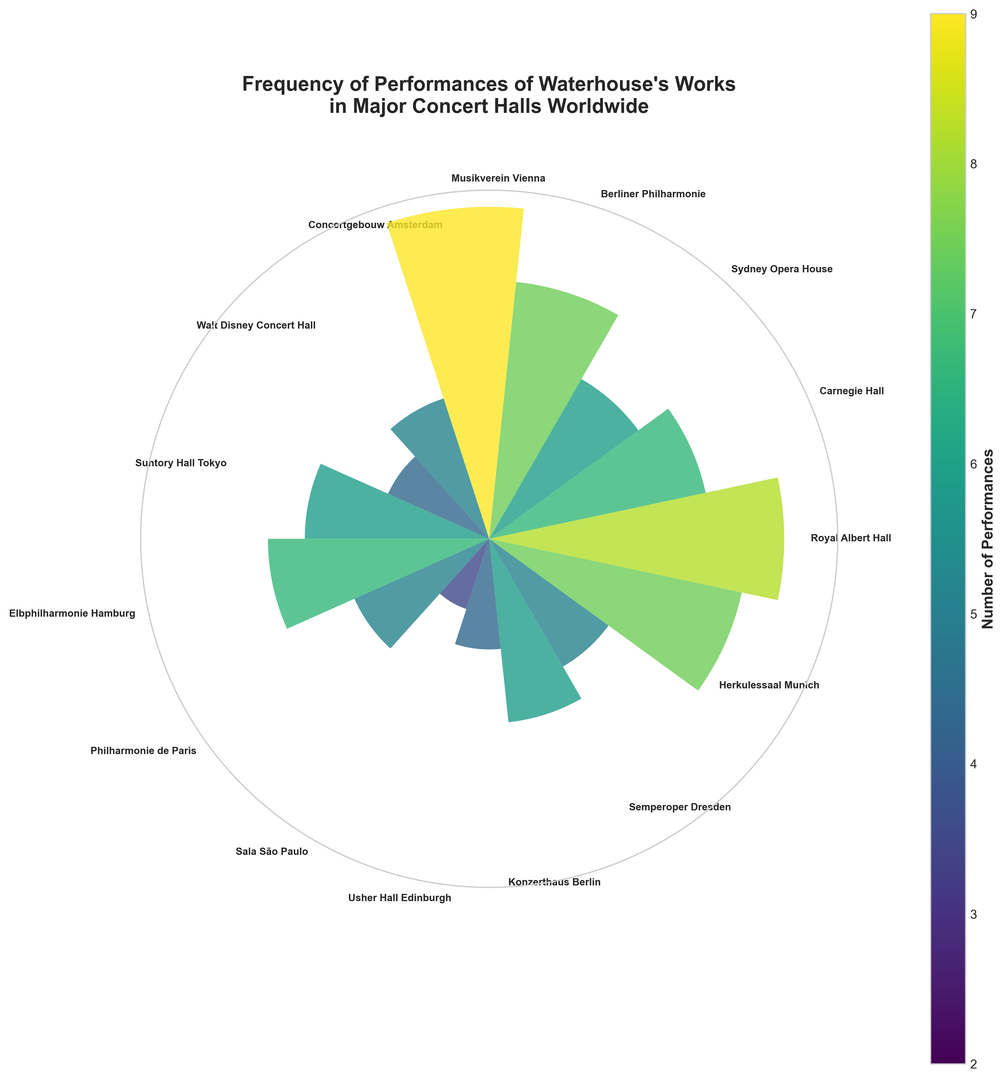What's the concert hall with the highest number of performances? Look at the tallest bar in the rose chart. Identify the concert hall label corresponding to this bar.
Answer: Musikverein Vienna Which concert hall has fewer performances, Walt Disney Concert Hall or Elbphilharmonie Hamburg? Compare the heights (or lengths) of the bars representing Walt Disney Concert Hall and Elbphilharmonie Hamburg. The shorter bar corresponds to fewer performances.
Answer: Walt Disney Concert Hall How many performances are there in total across all concert halls? Sum the number of performances for all the concert halls: 8 + 6 + 5 + 7 + 9 + 4 + 3 + 5 + 6 + 4 + 2 + 3 + 5 + 4 + 7.
Answer: 78 What's the average number of performances per concert hall? First, find the total number of performances across all concert halls, which is 78. Then, divide by the number of concert halls (15). 78 / 15 ≈ 5.2
Answer: 5.2 Which concert hall has exactly one performance more than the Sydney Opera House? Identify the number of performances for Sydney Opera House (5). Find the concert hall with 6 performances, which is one more than 5.
Answer: Carnegie Hall and Elbphilharmonie Hamburg Compare the number of performances at Concertgebouw Amsterdam and Herkulessaal Munich; which has more? Look at the heights of the bars corresponding to Concertgebouw Amsterdam and Herkulessaal Munich. The taller bar indicates more performances.
Answer: Herkulessaal Munich What's the difference in the number of performances between Royal Albert Hall and Sala São Paulo? Subtract the number of performances of Sala São Paulo (2) from Royal Albert Hall (8). 8 - 2 = 6
Answer: 6 Which concert hall has the same number of performances as Konzerthaus Berlin? Identify the number of performances for Konzerthaus Berlin (5). Find another concert hall with the same number of performances.
Answer: Sydney Opera House and Konzerthaus Berlin What is the range of performances across all concert halls? Find the difference between the maximum (9 at Musikverein Vienna) and the minimum (2 at Sala São Paulo) number of performances. 9 - 2 = 7
Answer: 7 